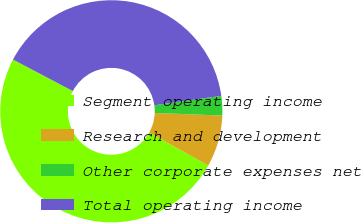Convert chart. <chart><loc_0><loc_0><loc_500><loc_500><pie_chart><fcel>Segment operating income<fcel>Research and development<fcel>Other corporate expenses net<fcel>Total operating income<nl><fcel>49.6%<fcel>7.5%<fcel>2.83%<fcel>40.07%<nl></chart> 